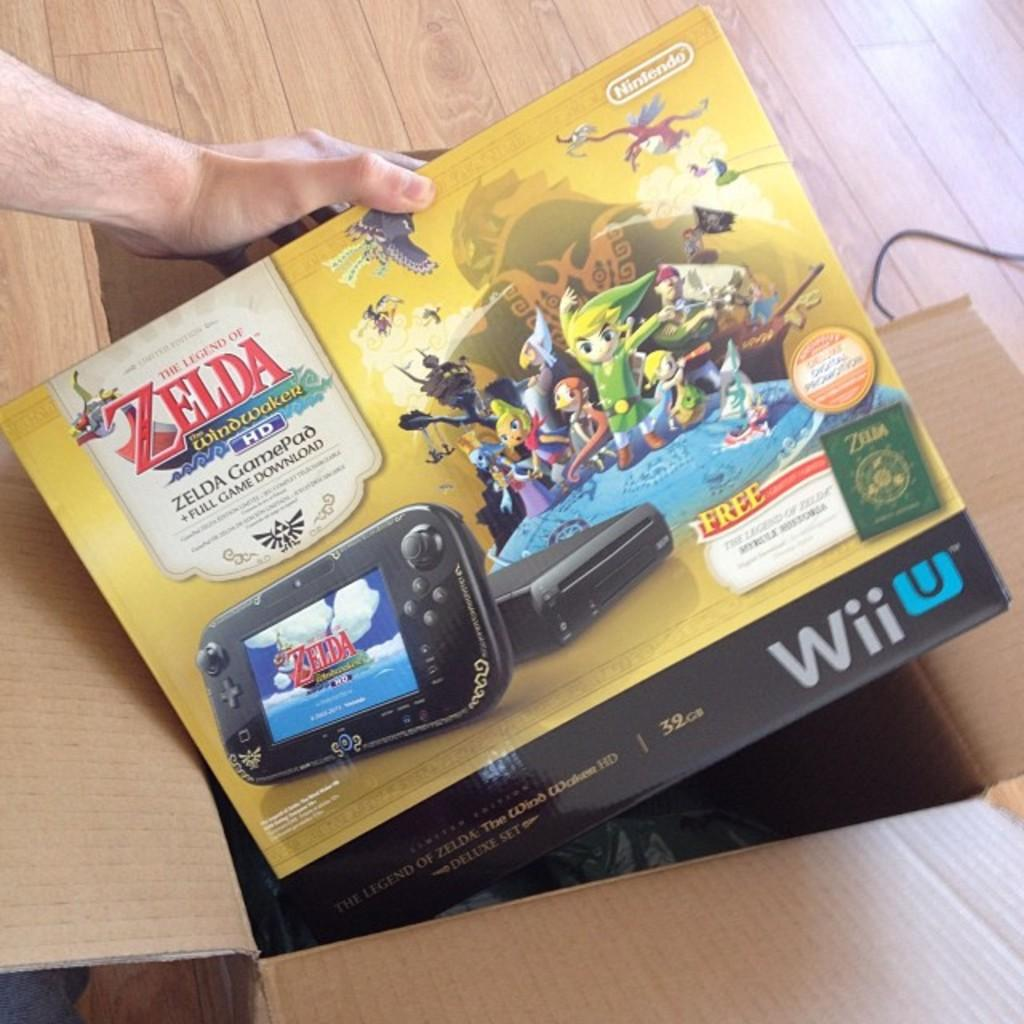<image>
Write a terse but informative summary of the picture. A man is holding a Zelda Nintendo game above a box. 